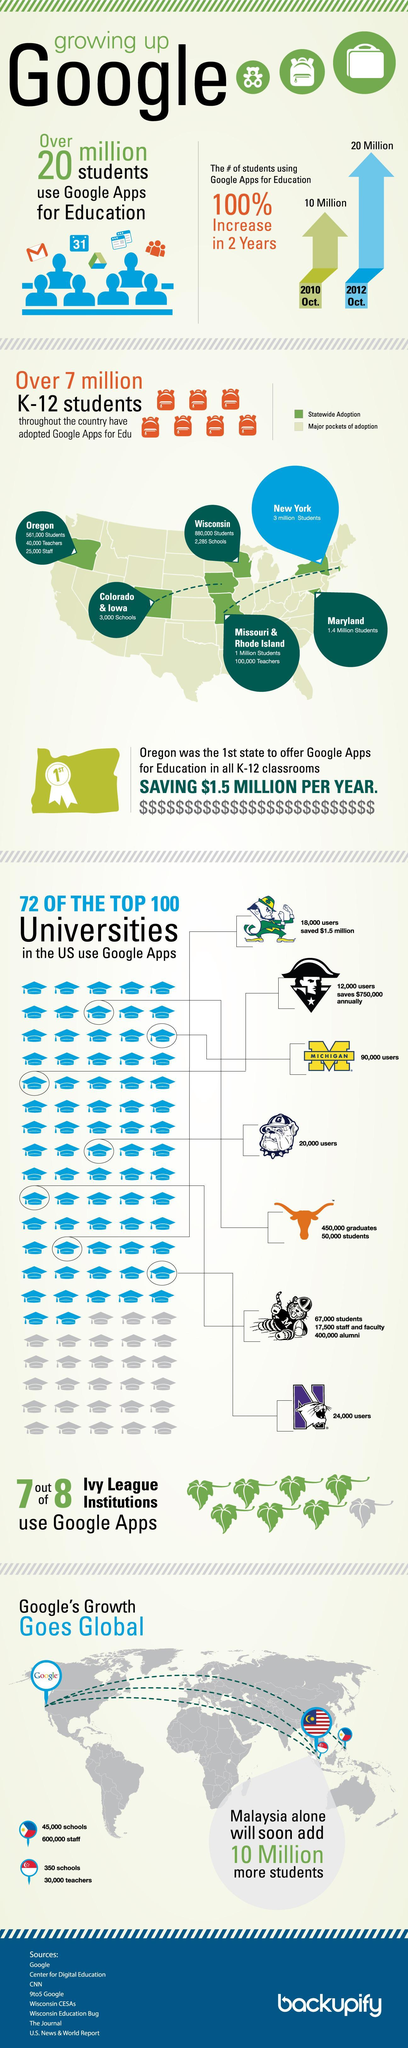By what number has students using Google Apps for Education increased during 2010-2012?
Answer the question with a short phrase. 10 Million How many states have adopted Google Apps for Edu Statewide? 7 Which state has the highest number of students adopting Google Apps statewide? New York How many sources are listed? 8 How many Ivy League Institutions did not use Google Apps? 1 out of 8 